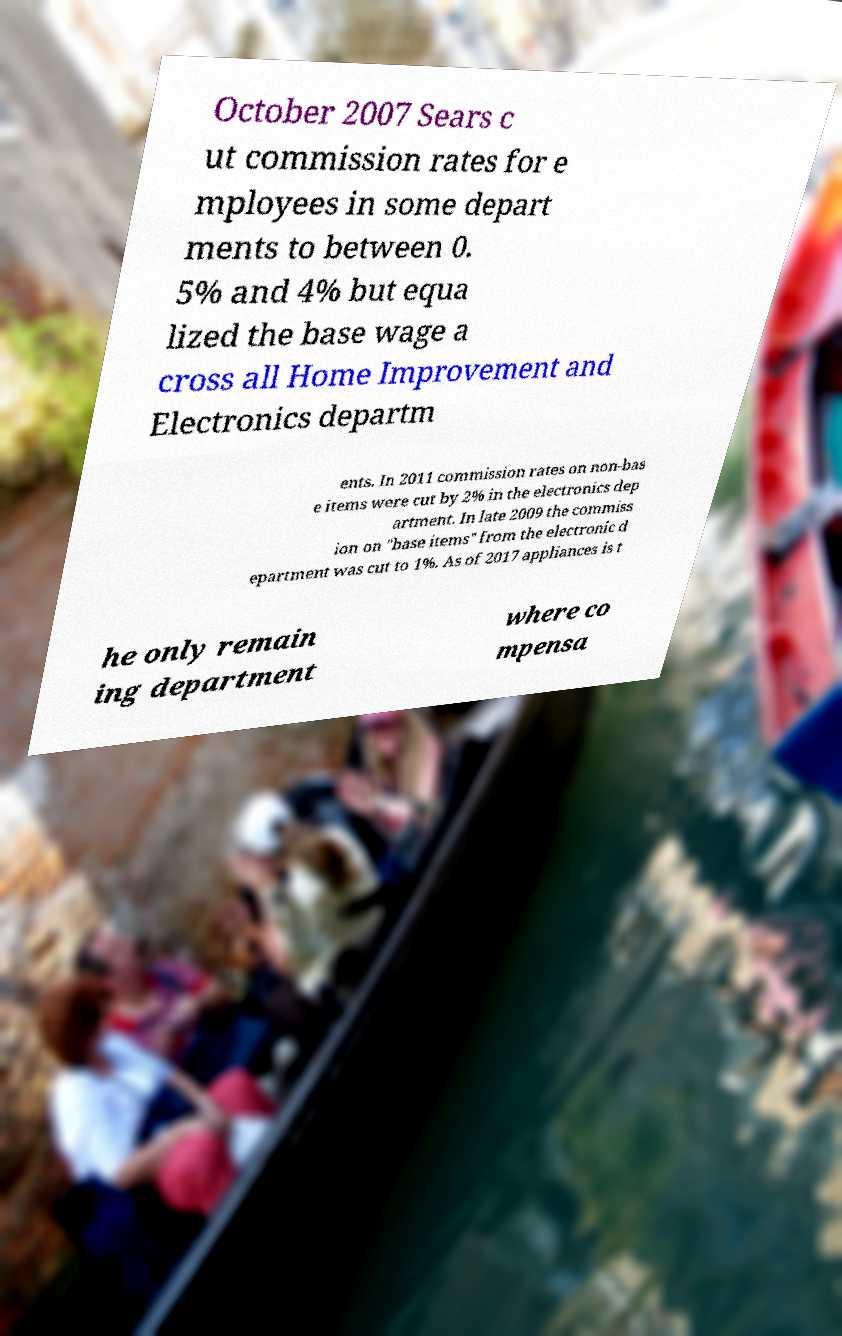Could you assist in decoding the text presented in this image and type it out clearly? October 2007 Sears c ut commission rates for e mployees in some depart ments to between 0. 5% and 4% but equa lized the base wage a cross all Home Improvement and Electronics departm ents. In 2011 commission rates on non-bas e items were cut by 2% in the electronics dep artment. In late 2009 the commiss ion on "base items" from the electronic d epartment was cut to 1%. As of 2017 appliances is t he only remain ing department where co mpensa 